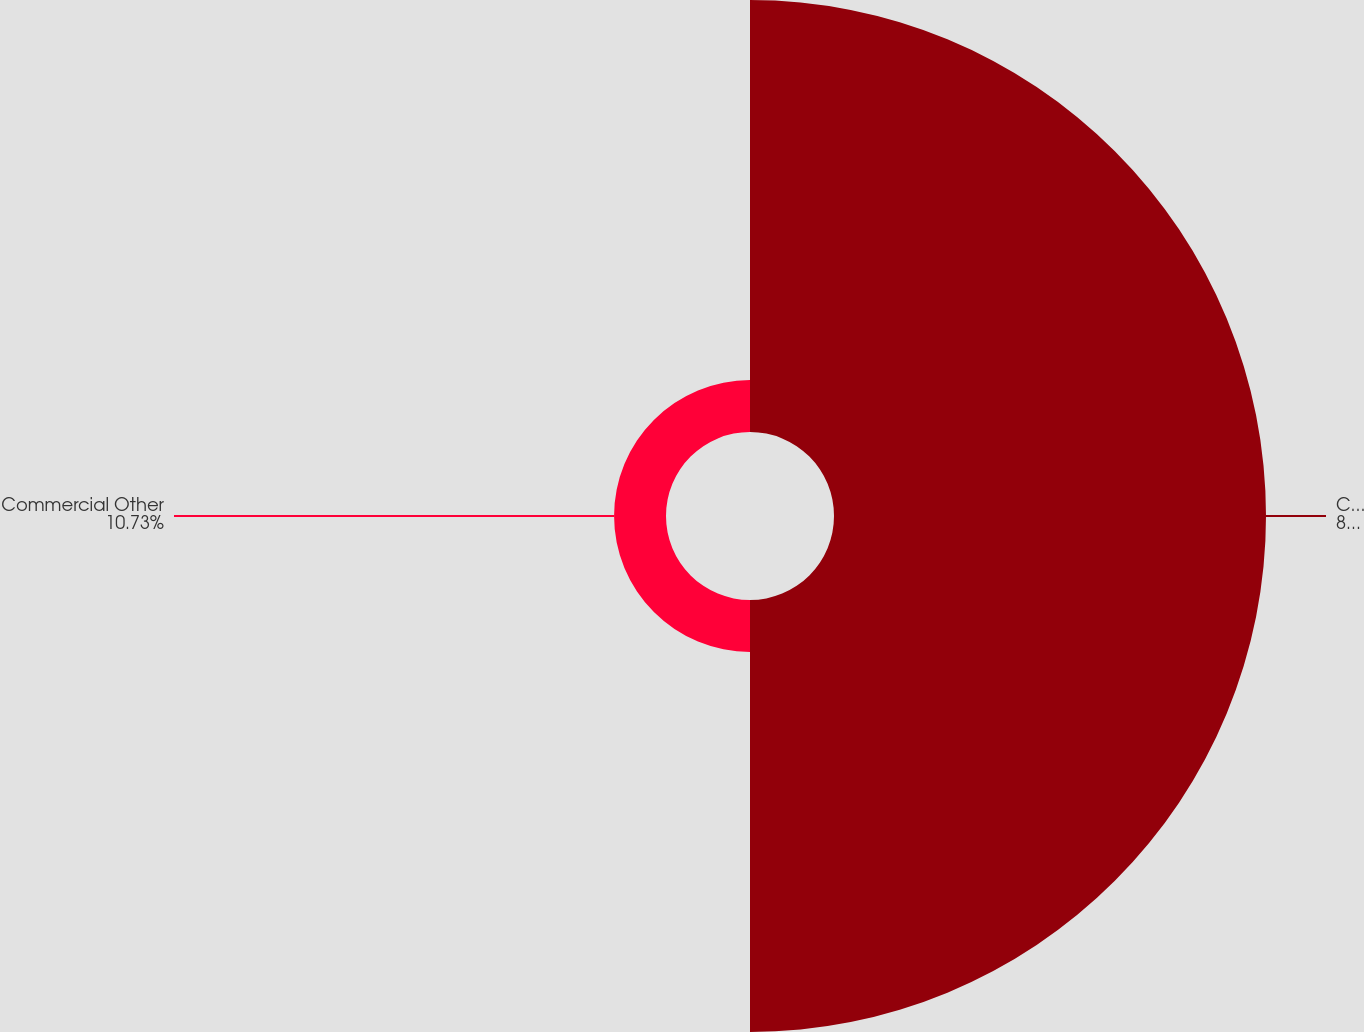Convert chart. <chart><loc_0><loc_0><loc_500><loc_500><pie_chart><fcel>Commercial Accounts<fcel>Commercial Other<nl><fcel>89.27%<fcel>10.73%<nl></chart> 